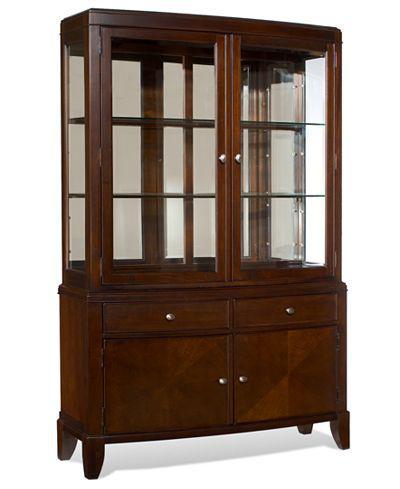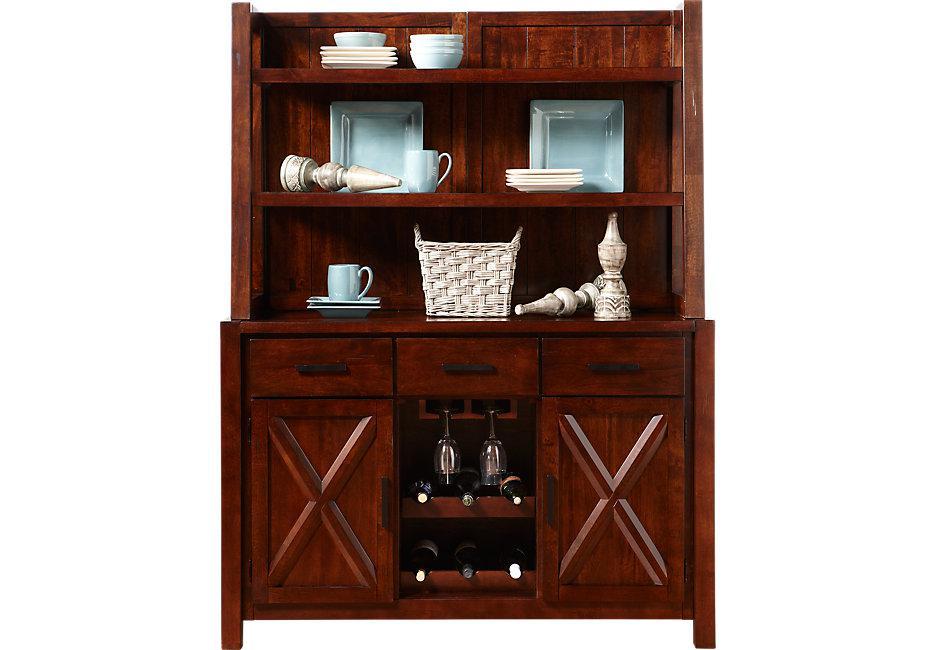The first image is the image on the left, the second image is the image on the right. For the images displayed, is the sentence "An image shows a two-door cabinet that is flat on top and has no visible feet." factually correct? Answer yes or no. No. The first image is the image on the left, the second image is the image on the right. For the images displayed, is the sentence "Each large wooden hutch as two equal size glass doors in the upper section and two equal size solid doors in the lower section." factually correct? Answer yes or no. No. 